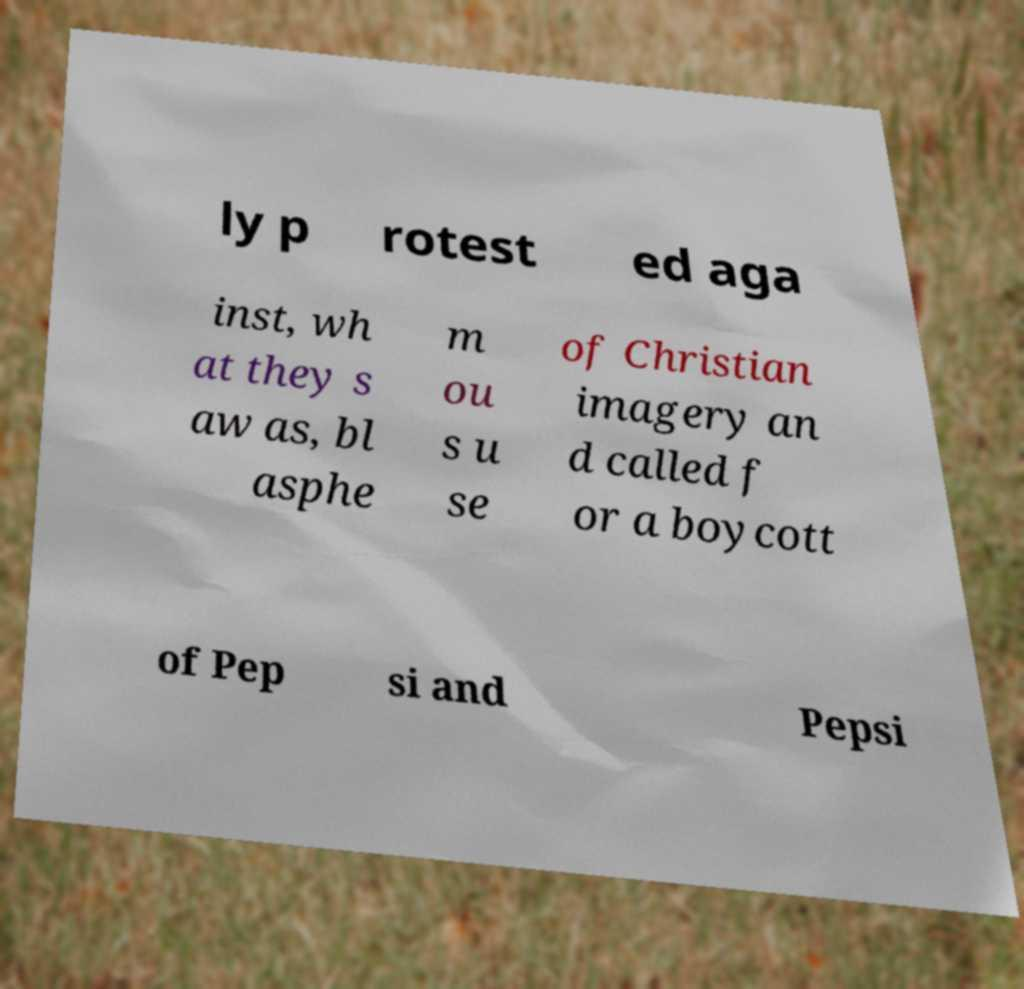Could you assist in decoding the text presented in this image and type it out clearly? ly p rotest ed aga inst, wh at they s aw as, bl asphe m ou s u se of Christian imagery an d called f or a boycott of Pep si and Pepsi 